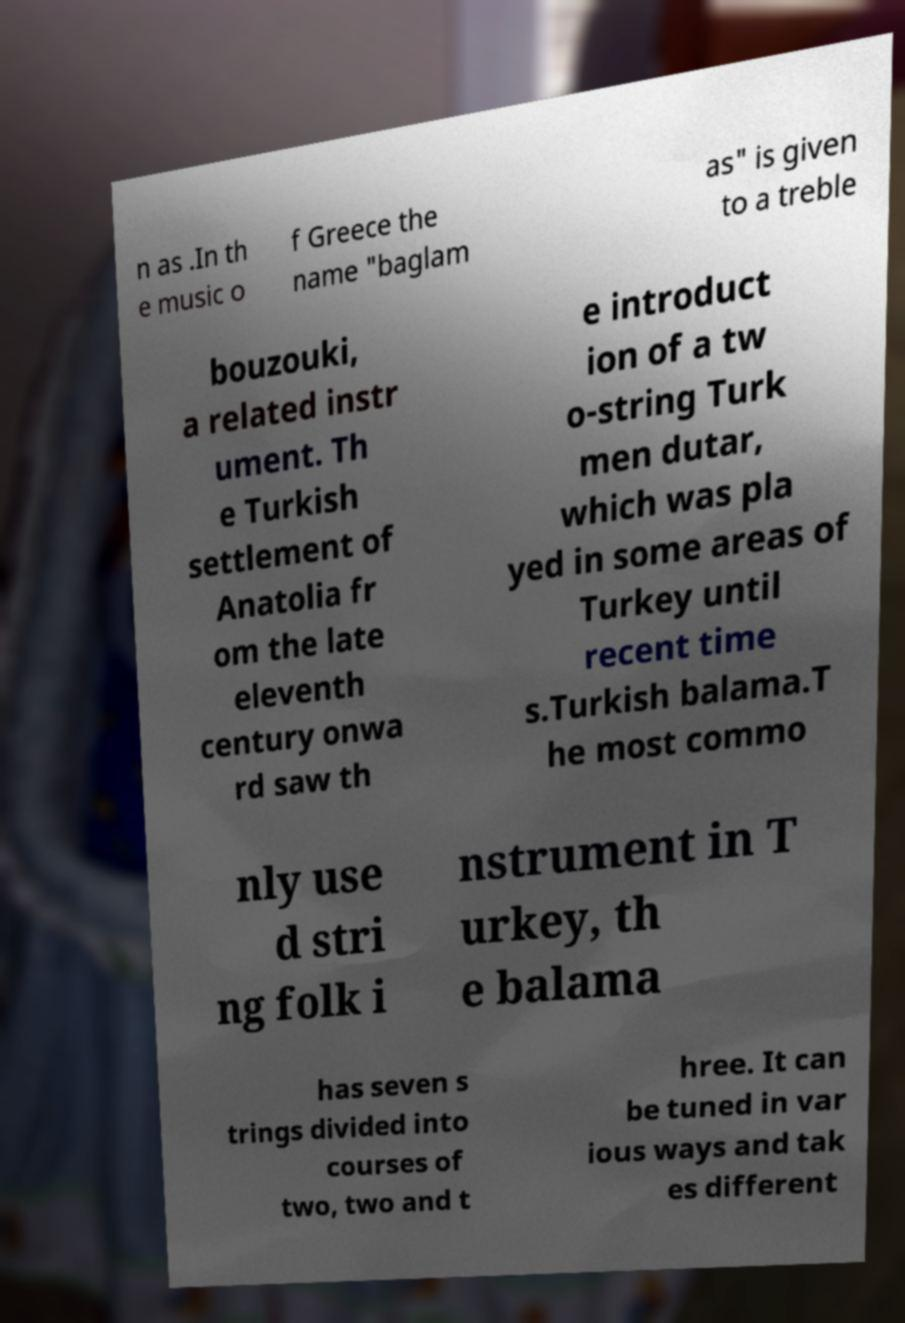There's text embedded in this image that I need extracted. Can you transcribe it verbatim? n as .In th e music o f Greece the name "baglam as" is given to a treble bouzouki, a related instr ument. Th e Turkish settlement of Anatolia fr om the late eleventh century onwa rd saw th e introduct ion of a tw o-string Turk men dutar, which was pla yed in some areas of Turkey until recent time s.Turkish balama.T he most commo nly use d stri ng folk i nstrument in T urkey, th e balama has seven s trings divided into courses of two, two and t hree. It can be tuned in var ious ways and tak es different 